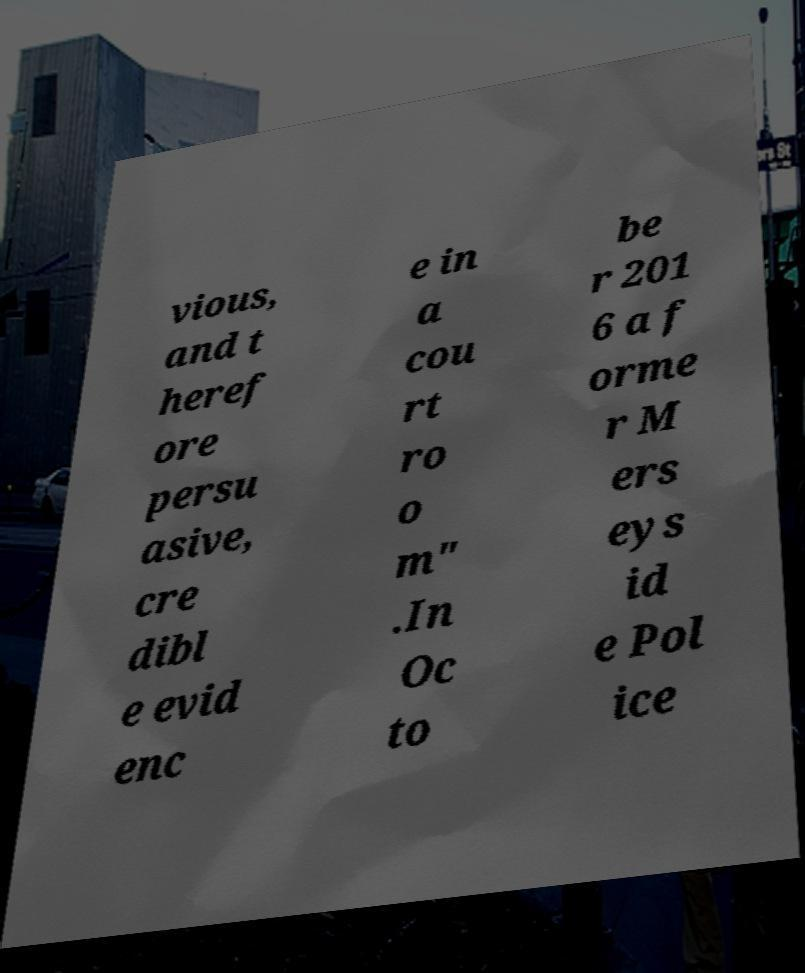There's text embedded in this image that I need extracted. Can you transcribe it verbatim? vious, and t heref ore persu asive, cre dibl e evid enc e in a cou rt ro o m" .In Oc to be r 201 6 a f orme r M ers eys id e Pol ice 